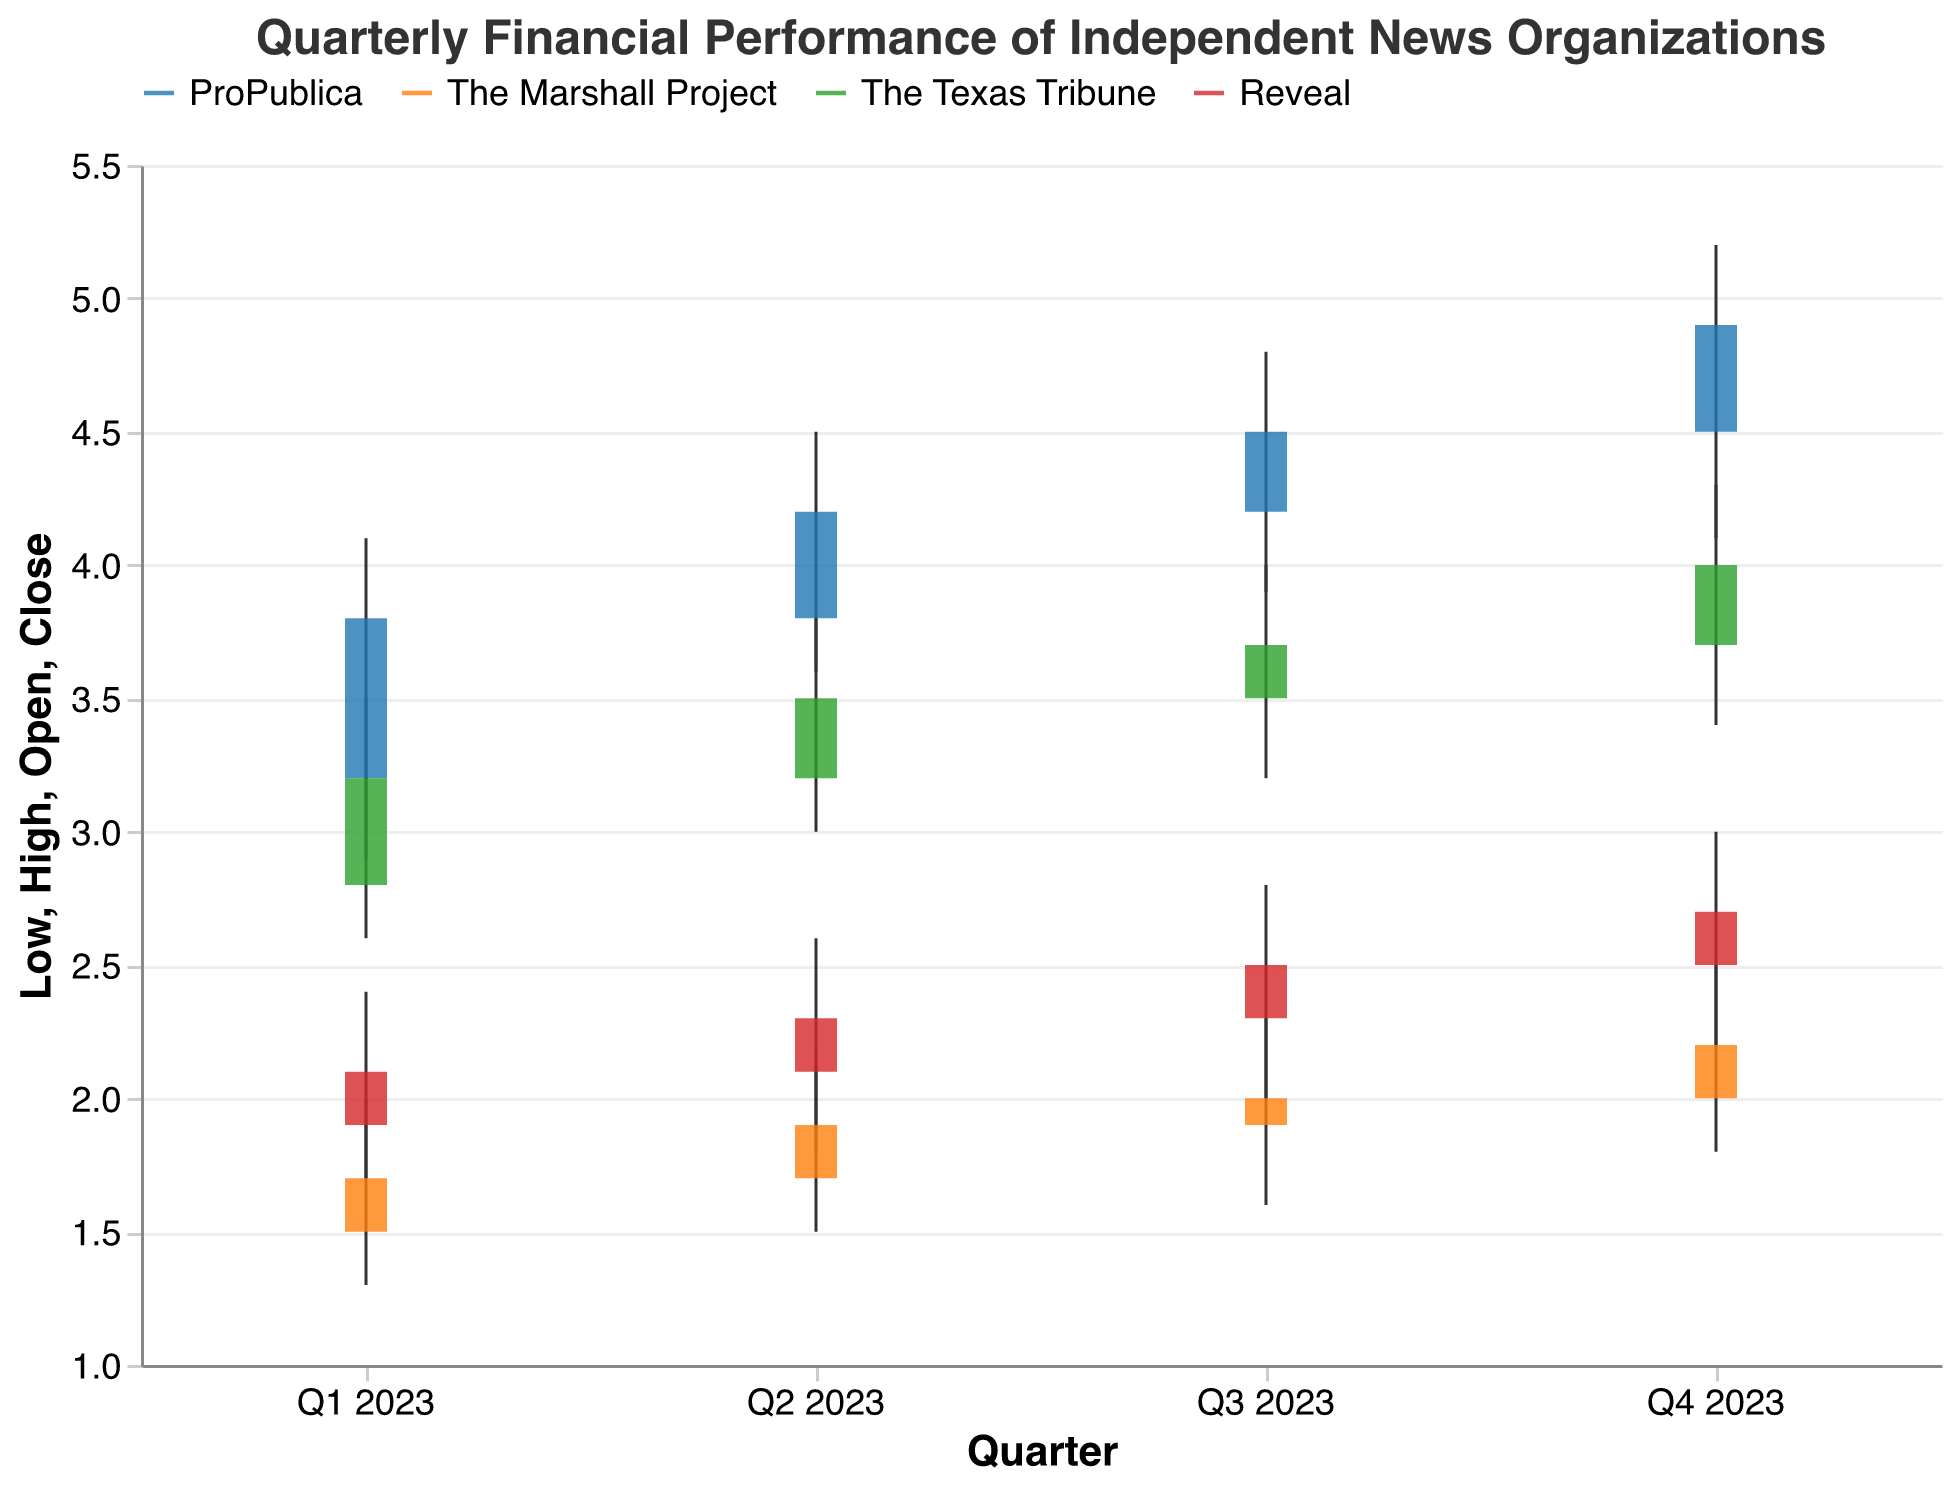What is the highest revenue recorded for any organization in Q4 2023? The highest revenue in Q4 2023 is indicated by the highest peak (High value), which for ProPublica is 5.2.
Answer: 5.2 How did the revenue for The Texas Tribune change from Q1 2023 to Q4 2023? For The Texas Tribune, comparing the closing values from Q1 2023 (3.2) to Q4 2023 (4.0), there is an increase of 0.8.
Answer: Increased by 0.8 Which organization had the lowest revenue in Q2 2023? The organization with the lowest revenue in Q2 2023 is identified by the lowest Low value, which is The Marshall Project with 1.5.
Answer: The Marshall Project Between Q1 2023 and Q3 2023, which organization saw the biggest increase in their closing revenue value? Calculate the difference between Q3 and Q1 closing values for each organization: 
ProPublica: 4.5 - 3.8 = 0.7
The Marshall Project: 2.0 - 1.7 = 0.3
The Texas Tribune: 3.7 - 3.2 = 0.5
Reveal: 2.5 - 2.1 = 0.4
The biggest increase is by ProPublica with an increase of 0.7.
Answer: ProPublica What was the average high revenue for Reveal across all quarters in 2023? Calculate the average of the high values for Reveal: 
(2.4 + 2.6 + 2.8 + 3.0) / 4 = 10.8 / 4 = 2.7
Answer: 2.7 Did any organization experience a decrease in revenue in multiple quarters during 2023? Analyze the close values of each organization over consecutive quarters to see if there was a drop:
ProPublica: (3.8 to 4.2, 4.2 to 4.5, 4.5 to 4.9) - No decrease
The Marshall Project: (1.7 to 1.9, 1.9 to 2.0, 2.0 to 2.2) - No decrease
The Texas Tribune: (3.2 to 3.5, 3.5 to 3.7, 3.7 to 4.0) - No decrease
Reveal: (2.1 to 2.3, 2.3 to 2.5, 2.5 to 2.7) - No decrease
None of the organizations experienced a decrease in revenue in multiple quarters.
Answer: No Comparing Q2 2023 and Q3 2023, which organization had the highest peak revenue growth? Calculate the difference in high values for each organization:
ProPublica: 4.8 - 4.5 = 0.3
The Marshall Project: 2.3 - 2.2 = 0.1
The Texas Tribune: 4.0 - 3.8 = 0.2
Reveal: 2.8 - 2.6 = 0.2
ProPublica has the highest peak revenue growth of 0.3.
Answer: ProPublica How much did ProPublica's opening revenue increase from Q1 2023 to Q4 2023? Subtract the opening revenue in Q1 2023 (3.2) from Q4 2023 (4.5): 4.5 - 3.2 = 1.3.
Answer: 1.3 